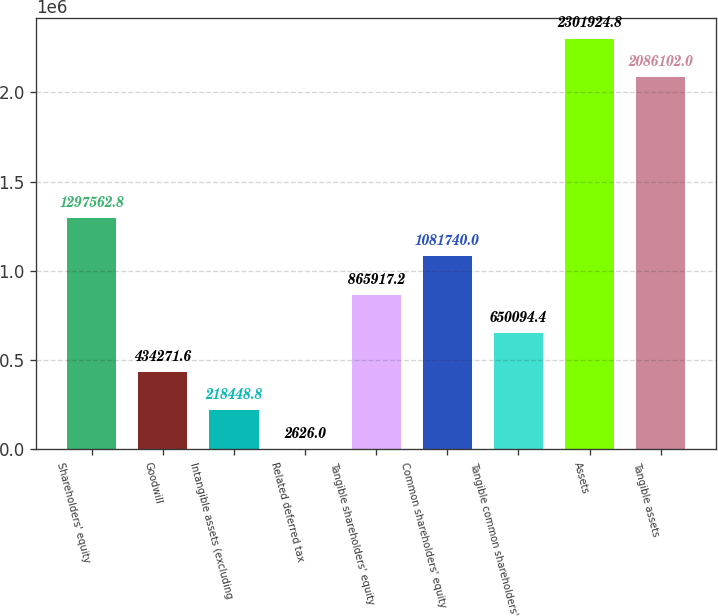Convert chart to OTSL. <chart><loc_0><loc_0><loc_500><loc_500><bar_chart><fcel>Shareholders' equity<fcel>Goodwill<fcel>Intangible assets (excluding<fcel>Related deferred tax<fcel>Tangible shareholders' equity<fcel>Common shareholders' equity<fcel>Tangible common shareholders'<fcel>Assets<fcel>Tangible assets<nl><fcel>1.29756e+06<fcel>434272<fcel>218449<fcel>2626<fcel>865917<fcel>1.08174e+06<fcel>650094<fcel>2.30192e+06<fcel>2.0861e+06<nl></chart> 